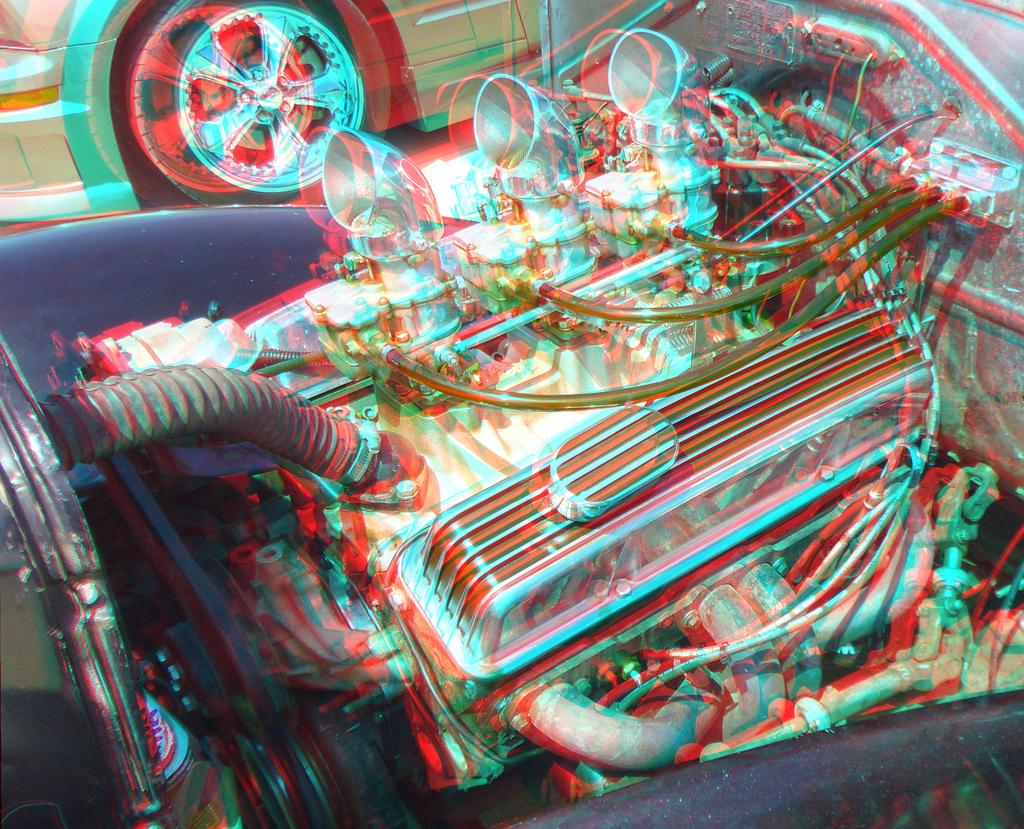What type of vehicle is present in the image? There is a car in the image. Can you describe any specific parts of the car that are visible? The engine of another car is visible in the image. What type of laborer is working on the car in the image? There is: There is no laborer present in the image, and no work is being done on the car. 